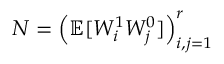<formula> <loc_0><loc_0><loc_500><loc_500>N = \left ( \mathbb { E } [ W _ { i } ^ { 1 } W _ { j } ^ { 0 } ] \right ) _ { i , j = 1 } ^ { r }</formula> 